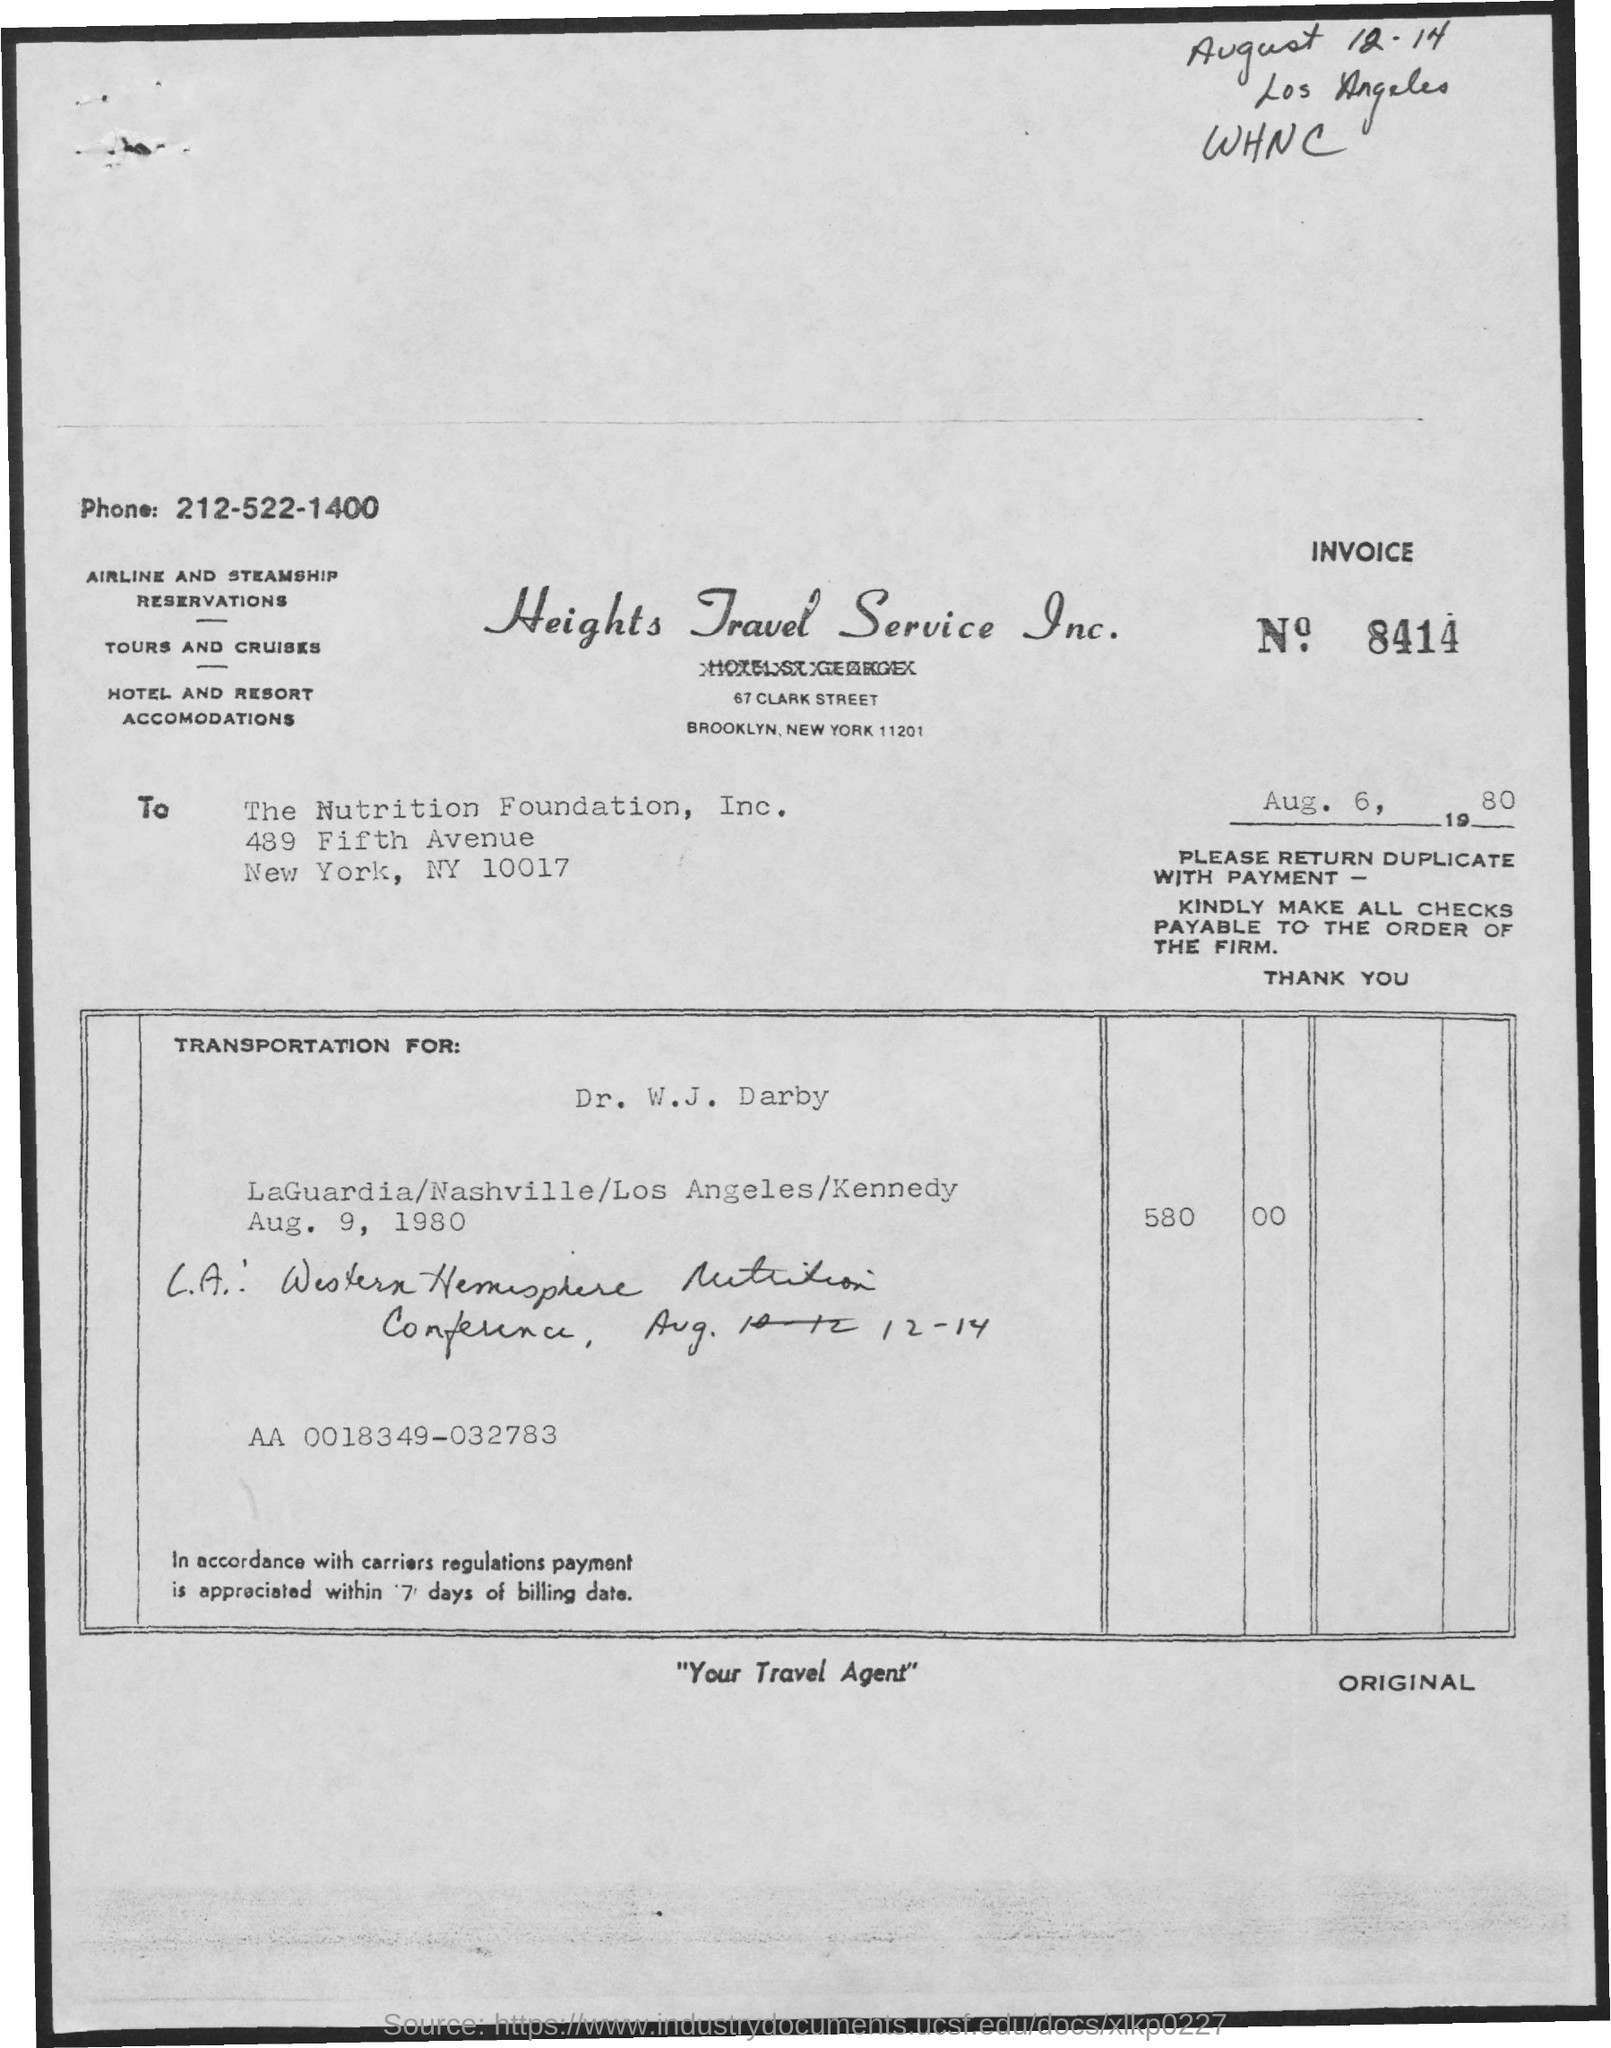What is the Invoice Number?
Offer a very short reply. 8414. What is the date below the invoice number?
Your response must be concise. Aug. 6, 1980. 